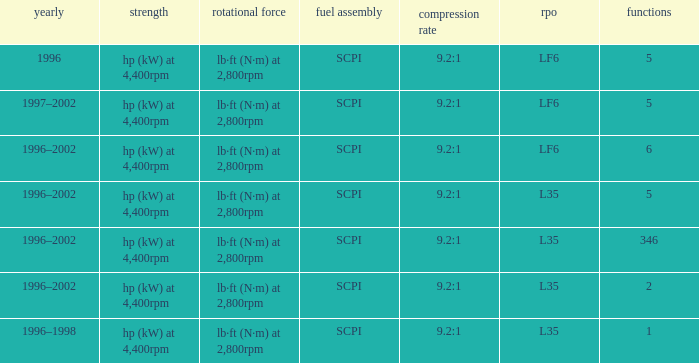What's the compression ratio of the model with L35 RPO and 5 applications? 9.2:1. 